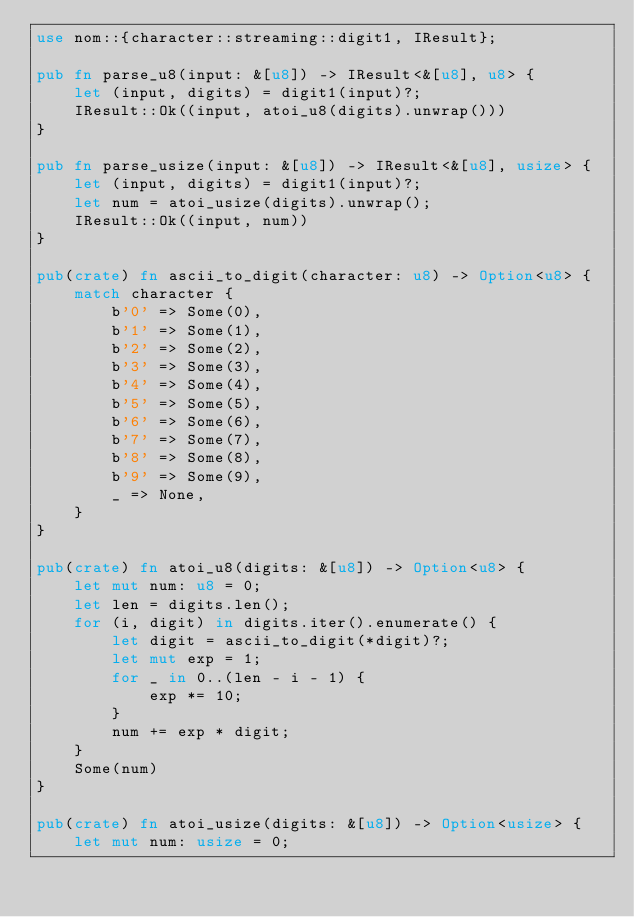<code> <loc_0><loc_0><loc_500><loc_500><_Rust_>use nom::{character::streaming::digit1, IResult};

pub fn parse_u8(input: &[u8]) -> IResult<&[u8], u8> {
    let (input, digits) = digit1(input)?;
    IResult::Ok((input, atoi_u8(digits).unwrap()))
}

pub fn parse_usize(input: &[u8]) -> IResult<&[u8], usize> {
    let (input, digits) = digit1(input)?;
    let num = atoi_usize(digits).unwrap();
    IResult::Ok((input, num))
}

pub(crate) fn ascii_to_digit(character: u8) -> Option<u8> {
    match character {
        b'0' => Some(0),
        b'1' => Some(1),
        b'2' => Some(2),
        b'3' => Some(3),
        b'4' => Some(4),
        b'5' => Some(5),
        b'6' => Some(6),
        b'7' => Some(7),
        b'8' => Some(8),
        b'9' => Some(9),
        _ => None,
    }
}

pub(crate) fn atoi_u8(digits: &[u8]) -> Option<u8> {
    let mut num: u8 = 0;
    let len = digits.len();
    for (i, digit) in digits.iter().enumerate() {
        let digit = ascii_to_digit(*digit)?;
        let mut exp = 1;
        for _ in 0..(len - i - 1) {
            exp *= 10;
        }
        num += exp * digit;
    }
    Some(num)
}

pub(crate) fn atoi_usize(digits: &[u8]) -> Option<usize> {
    let mut num: usize = 0;</code> 